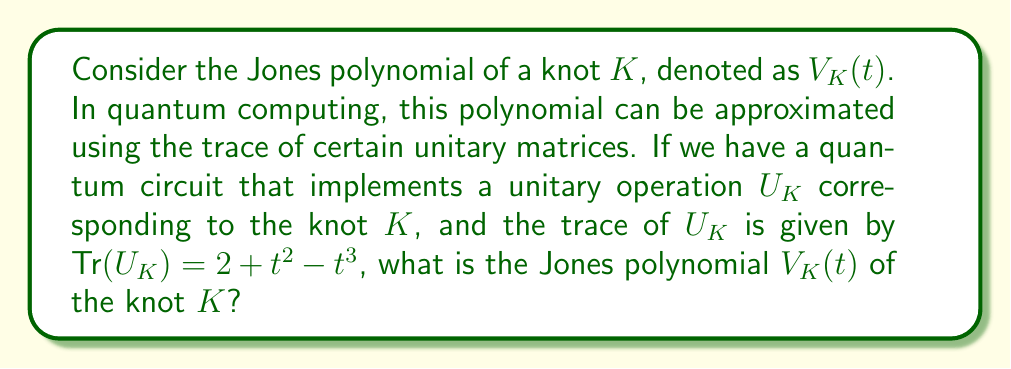What is the answer to this math problem? To solve this problem, we'll follow these steps:

1) Recall the relationship between the trace of the unitary matrix $U_K$ and the Jones polynomial $V_K(t)$:

   $$\text{Tr}(U_K) = d \cdot V_K(t)$$

   where $d = -t^{1/2} - t^{-1/2}$ is the quantum dimension.

2) We're given that $\text{Tr}(U_K) = 2 + t^2 - t^3$. Let's substitute this into the equation:

   $$2 + t^2 - t^3 = (-t^{1/2} - t^{-1/2}) \cdot V_K(t)$$

3) To solve for $V_K(t)$, we need to divide both sides by $(-t^{1/2} - t^{-1/2})$:

   $$V_K(t) = \frac{2 + t^2 - t^3}{-t^{1/2} - t^{-1/2}}$$

4) To simplify this, let's multiply both numerator and denominator by $t^{1/2}$:

   $$V_K(t) = \frac{(2 + t^2 - t^3) \cdot t^{1/2}}{(-t^{1/2} - t^{-1/2}) \cdot t^{1/2}} = \frac{2t^{1/2} + t^{5/2} - t^{7/2}}{-t - 1}$$

5) Simplify the numerator:

   $$V_K(t) = \frac{2t^{1/2} + t^{5/2} - t^{7/2}}{-(t + 1)}$$

6) Finally, we can write this as:

   $$V_K(t) = \frac{t^{7/2} - t^{5/2} - 2t^{1/2}}{t + 1}$$

This is the Jones polynomial for the knot $K$.
Answer: $V_K(t) = \frac{t^{7/2} - t^{5/2} - 2t^{1/2}}{t + 1}$ 